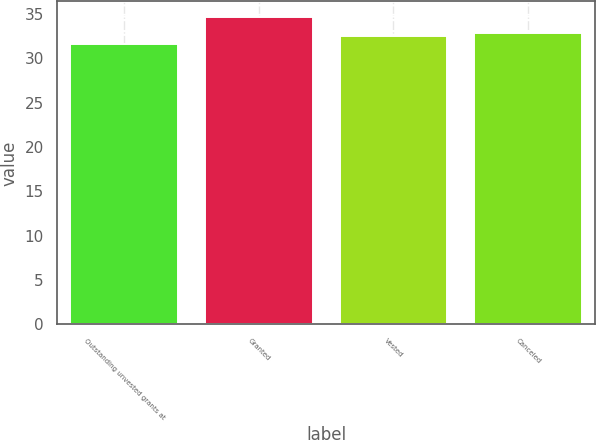Convert chart. <chart><loc_0><loc_0><loc_500><loc_500><bar_chart><fcel>Outstanding unvested grants at<fcel>Granted<fcel>Vested<fcel>Canceled<nl><fcel>31.64<fcel>34.69<fcel>32.47<fcel>32.9<nl></chart> 